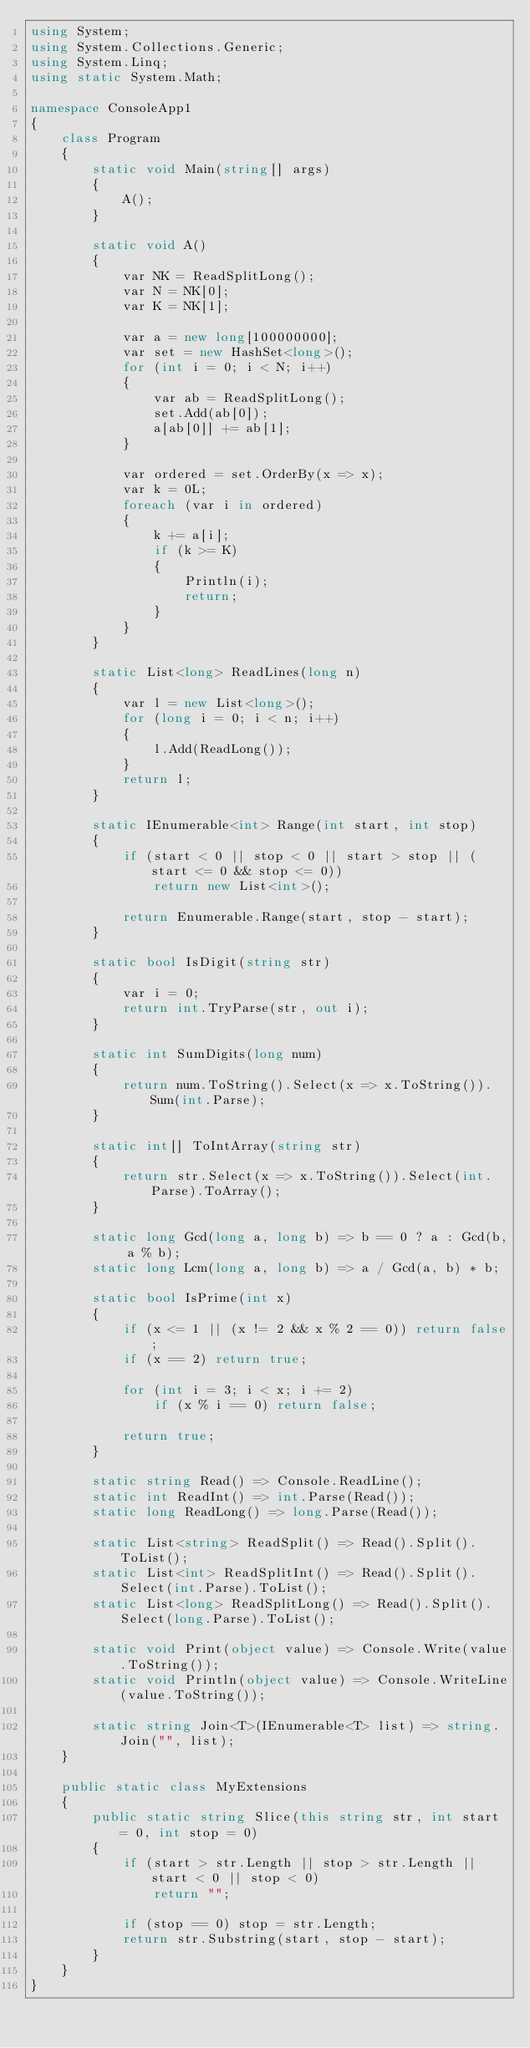<code> <loc_0><loc_0><loc_500><loc_500><_C#_>using System;
using System.Collections.Generic;
using System.Linq;
using static System.Math;

namespace ConsoleApp1
{
    class Program
    {
        static void Main(string[] args)
        {
            A();
        }

        static void A()
        {
            var NK = ReadSplitLong();
            var N = NK[0];
            var K = NK[1];

            var a = new long[100000000];
            var set = new HashSet<long>();
            for (int i = 0; i < N; i++)
            {
                var ab = ReadSplitLong();
                set.Add(ab[0]);
                a[ab[0]] += ab[1];
            }

            var ordered = set.OrderBy(x => x);
            var k = 0L;
            foreach (var i in ordered)
            {
                k += a[i];
                if (k >= K)
                {
                    Println(i);
                    return;
                }
            }
        }

        static List<long> ReadLines(long n)
        {
            var l = new List<long>();
            for (long i = 0; i < n; i++)
            {
                l.Add(ReadLong());
            }
            return l;
        }

        static IEnumerable<int> Range(int start, int stop)
        {
            if (start < 0 || stop < 0 || start > stop || (start <= 0 && stop <= 0))
                return new List<int>();

            return Enumerable.Range(start, stop - start);
        }

        static bool IsDigit(string str)
        {
            var i = 0;
            return int.TryParse(str, out i);
        }

        static int SumDigits(long num)
        {
            return num.ToString().Select(x => x.ToString()).Sum(int.Parse);
        }

        static int[] ToIntArray(string str)
        {
            return str.Select(x => x.ToString()).Select(int.Parse).ToArray();
        }

        static long Gcd(long a, long b) => b == 0 ? a : Gcd(b, a % b);
        static long Lcm(long a, long b) => a / Gcd(a, b) * b;

        static bool IsPrime(int x)
        {
            if (x <= 1 || (x != 2 && x % 2 == 0)) return false;
            if (x == 2) return true;

            for (int i = 3; i < x; i += 2)
                if (x % i == 0) return false;

            return true;
        }

        static string Read() => Console.ReadLine();
        static int ReadInt() => int.Parse(Read());
        static long ReadLong() => long.Parse(Read());

        static List<string> ReadSplit() => Read().Split().ToList();
        static List<int> ReadSplitInt() => Read().Split().Select(int.Parse).ToList();
        static List<long> ReadSplitLong() => Read().Split().Select(long.Parse).ToList();

        static void Print(object value) => Console.Write(value.ToString());
        static void Println(object value) => Console.WriteLine(value.ToString());

        static string Join<T>(IEnumerable<T> list) => string.Join("", list);
    }

    public static class MyExtensions
    {
        public static string Slice(this string str, int start = 0, int stop = 0)
        {
            if (start > str.Length || stop > str.Length || start < 0 || stop < 0)
                return "";

            if (stop == 0) stop = str.Length;
            return str.Substring(start, stop - start);
        }
    }
}</code> 